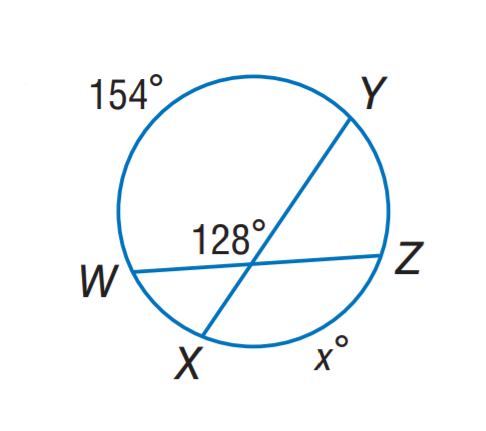Answer the mathemtical geometry problem and directly provide the correct option letter.
Question: Find x.
Choices: A: 92 B: 102 C: 128 D: 154 B 